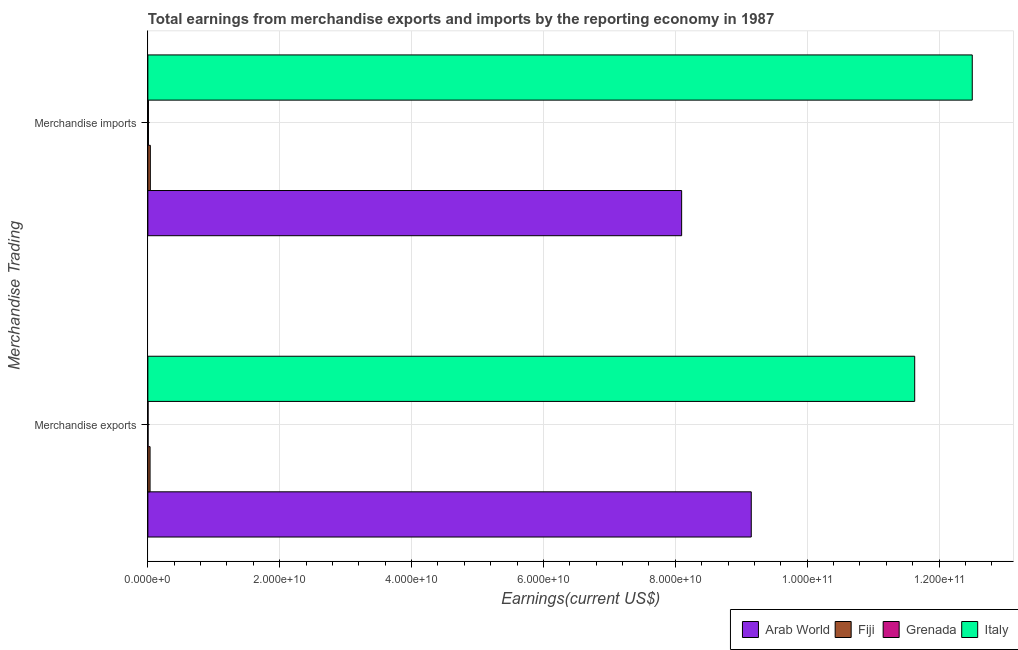Are the number of bars per tick equal to the number of legend labels?
Offer a very short reply. Yes. How many bars are there on the 1st tick from the bottom?
Your answer should be very brief. 4. What is the label of the 1st group of bars from the top?
Offer a terse response. Merchandise imports. What is the earnings from merchandise exports in Arab World?
Your response must be concise. 9.15e+1. Across all countries, what is the maximum earnings from merchandise imports?
Offer a terse response. 1.25e+11. Across all countries, what is the minimum earnings from merchandise imports?
Your answer should be very brief. 8.87e+07. In which country was the earnings from merchandise exports minimum?
Provide a succinct answer. Grenada. What is the total earnings from merchandise exports in the graph?
Offer a terse response. 2.08e+11. What is the difference between the earnings from merchandise exports in Arab World and that in Italy?
Provide a succinct answer. -2.48e+1. What is the difference between the earnings from merchandise imports in Fiji and the earnings from merchandise exports in Arab World?
Provide a succinct answer. -9.11e+1. What is the average earnings from merchandise exports per country?
Your response must be concise. 5.20e+1. What is the difference between the earnings from merchandise imports and earnings from merchandise exports in Italy?
Ensure brevity in your answer.  8.73e+09. In how many countries, is the earnings from merchandise imports greater than 48000000000 US$?
Offer a very short reply. 2. What is the ratio of the earnings from merchandise imports in Fiji to that in Grenada?
Keep it short and to the point. 4.22. Is the earnings from merchandise imports in Arab World less than that in Fiji?
Ensure brevity in your answer.  No. What does the 1st bar from the bottom in Merchandise exports represents?
Give a very brief answer. Arab World. How many bars are there?
Make the answer very short. 8. Where does the legend appear in the graph?
Your answer should be compact. Bottom right. How are the legend labels stacked?
Make the answer very short. Horizontal. What is the title of the graph?
Offer a terse response. Total earnings from merchandise exports and imports by the reporting economy in 1987. What is the label or title of the X-axis?
Provide a succinct answer. Earnings(current US$). What is the label or title of the Y-axis?
Your response must be concise. Merchandise Trading. What is the Earnings(current US$) of Arab World in Merchandise exports?
Keep it short and to the point. 9.15e+1. What is the Earnings(current US$) in Fiji in Merchandise exports?
Offer a very short reply. 3.32e+08. What is the Earnings(current US$) of Grenada in Merchandise exports?
Provide a succinct answer. 2.98e+07. What is the Earnings(current US$) of Italy in Merchandise exports?
Provide a short and direct response. 1.16e+11. What is the Earnings(current US$) of Arab World in Merchandise imports?
Offer a terse response. 8.10e+1. What is the Earnings(current US$) in Fiji in Merchandise imports?
Give a very brief answer. 3.74e+08. What is the Earnings(current US$) in Grenada in Merchandise imports?
Offer a very short reply. 8.87e+07. What is the Earnings(current US$) in Italy in Merchandise imports?
Make the answer very short. 1.25e+11. Across all Merchandise Trading, what is the maximum Earnings(current US$) in Arab World?
Offer a very short reply. 9.15e+1. Across all Merchandise Trading, what is the maximum Earnings(current US$) in Fiji?
Offer a terse response. 3.74e+08. Across all Merchandise Trading, what is the maximum Earnings(current US$) in Grenada?
Ensure brevity in your answer.  8.87e+07. Across all Merchandise Trading, what is the maximum Earnings(current US$) of Italy?
Your answer should be compact. 1.25e+11. Across all Merchandise Trading, what is the minimum Earnings(current US$) of Arab World?
Offer a very short reply. 8.10e+1. Across all Merchandise Trading, what is the minimum Earnings(current US$) of Fiji?
Offer a very short reply. 3.32e+08. Across all Merchandise Trading, what is the minimum Earnings(current US$) in Grenada?
Give a very brief answer. 2.98e+07. Across all Merchandise Trading, what is the minimum Earnings(current US$) of Italy?
Keep it short and to the point. 1.16e+11. What is the total Earnings(current US$) of Arab World in the graph?
Provide a succinct answer. 1.72e+11. What is the total Earnings(current US$) of Fiji in the graph?
Provide a succinct answer. 7.06e+08. What is the total Earnings(current US$) of Grenada in the graph?
Provide a succinct answer. 1.18e+08. What is the total Earnings(current US$) in Italy in the graph?
Ensure brevity in your answer.  2.41e+11. What is the difference between the Earnings(current US$) in Arab World in Merchandise exports and that in Merchandise imports?
Offer a terse response. 1.06e+1. What is the difference between the Earnings(current US$) in Fiji in Merchandise exports and that in Merchandise imports?
Your answer should be very brief. -4.21e+07. What is the difference between the Earnings(current US$) in Grenada in Merchandise exports and that in Merchandise imports?
Provide a short and direct response. -5.89e+07. What is the difference between the Earnings(current US$) in Italy in Merchandise exports and that in Merchandise imports?
Your answer should be very brief. -8.73e+09. What is the difference between the Earnings(current US$) in Arab World in Merchandise exports and the Earnings(current US$) in Fiji in Merchandise imports?
Provide a succinct answer. 9.11e+1. What is the difference between the Earnings(current US$) in Arab World in Merchandise exports and the Earnings(current US$) in Grenada in Merchandise imports?
Ensure brevity in your answer.  9.14e+1. What is the difference between the Earnings(current US$) of Arab World in Merchandise exports and the Earnings(current US$) of Italy in Merchandise imports?
Your answer should be very brief. -3.35e+1. What is the difference between the Earnings(current US$) of Fiji in Merchandise exports and the Earnings(current US$) of Grenada in Merchandise imports?
Provide a short and direct response. 2.43e+08. What is the difference between the Earnings(current US$) in Fiji in Merchandise exports and the Earnings(current US$) in Italy in Merchandise imports?
Your answer should be compact. -1.25e+11. What is the difference between the Earnings(current US$) in Grenada in Merchandise exports and the Earnings(current US$) in Italy in Merchandise imports?
Your answer should be very brief. -1.25e+11. What is the average Earnings(current US$) in Arab World per Merchandise Trading?
Your answer should be very brief. 8.62e+1. What is the average Earnings(current US$) of Fiji per Merchandise Trading?
Ensure brevity in your answer.  3.53e+08. What is the average Earnings(current US$) in Grenada per Merchandise Trading?
Ensure brevity in your answer.  5.92e+07. What is the average Earnings(current US$) of Italy per Merchandise Trading?
Your answer should be very brief. 1.21e+11. What is the difference between the Earnings(current US$) of Arab World and Earnings(current US$) of Fiji in Merchandise exports?
Keep it short and to the point. 9.12e+1. What is the difference between the Earnings(current US$) of Arab World and Earnings(current US$) of Grenada in Merchandise exports?
Provide a short and direct response. 9.15e+1. What is the difference between the Earnings(current US$) of Arab World and Earnings(current US$) of Italy in Merchandise exports?
Provide a succinct answer. -2.48e+1. What is the difference between the Earnings(current US$) in Fiji and Earnings(current US$) in Grenada in Merchandise exports?
Your answer should be very brief. 3.02e+08. What is the difference between the Earnings(current US$) of Fiji and Earnings(current US$) of Italy in Merchandise exports?
Offer a very short reply. -1.16e+11. What is the difference between the Earnings(current US$) in Grenada and Earnings(current US$) in Italy in Merchandise exports?
Provide a short and direct response. -1.16e+11. What is the difference between the Earnings(current US$) in Arab World and Earnings(current US$) in Fiji in Merchandise imports?
Make the answer very short. 8.06e+1. What is the difference between the Earnings(current US$) in Arab World and Earnings(current US$) in Grenada in Merchandise imports?
Your answer should be very brief. 8.09e+1. What is the difference between the Earnings(current US$) in Arab World and Earnings(current US$) in Italy in Merchandise imports?
Give a very brief answer. -4.41e+1. What is the difference between the Earnings(current US$) in Fiji and Earnings(current US$) in Grenada in Merchandise imports?
Your answer should be compact. 2.85e+08. What is the difference between the Earnings(current US$) in Fiji and Earnings(current US$) in Italy in Merchandise imports?
Offer a terse response. -1.25e+11. What is the difference between the Earnings(current US$) in Grenada and Earnings(current US$) in Italy in Merchandise imports?
Provide a short and direct response. -1.25e+11. What is the ratio of the Earnings(current US$) in Arab World in Merchandise exports to that in Merchandise imports?
Keep it short and to the point. 1.13. What is the ratio of the Earnings(current US$) in Fiji in Merchandise exports to that in Merchandise imports?
Offer a terse response. 0.89. What is the ratio of the Earnings(current US$) of Grenada in Merchandise exports to that in Merchandise imports?
Provide a succinct answer. 0.34. What is the ratio of the Earnings(current US$) of Italy in Merchandise exports to that in Merchandise imports?
Provide a succinct answer. 0.93. What is the difference between the highest and the second highest Earnings(current US$) in Arab World?
Provide a short and direct response. 1.06e+1. What is the difference between the highest and the second highest Earnings(current US$) in Fiji?
Ensure brevity in your answer.  4.21e+07. What is the difference between the highest and the second highest Earnings(current US$) in Grenada?
Provide a succinct answer. 5.89e+07. What is the difference between the highest and the second highest Earnings(current US$) of Italy?
Offer a terse response. 8.73e+09. What is the difference between the highest and the lowest Earnings(current US$) in Arab World?
Give a very brief answer. 1.06e+1. What is the difference between the highest and the lowest Earnings(current US$) in Fiji?
Your response must be concise. 4.21e+07. What is the difference between the highest and the lowest Earnings(current US$) of Grenada?
Provide a succinct answer. 5.89e+07. What is the difference between the highest and the lowest Earnings(current US$) of Italy?
Give a very brief answer. 8.73e+09. 